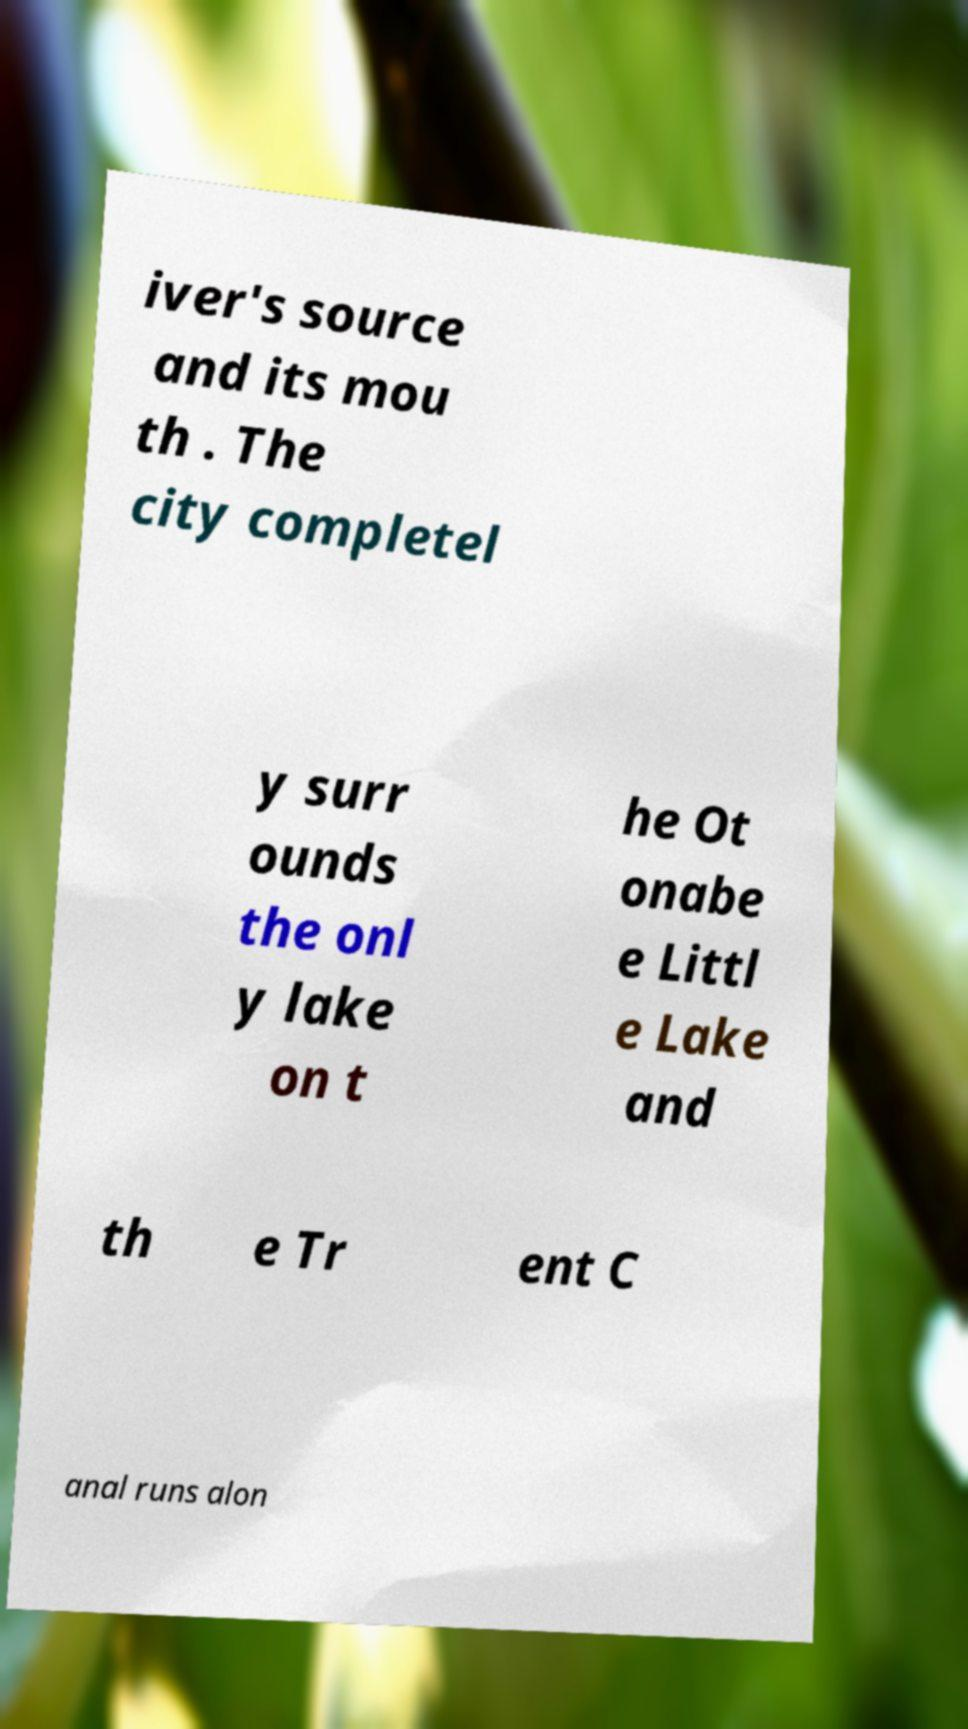What messages or text are displayed in this image? I need them in a readable, typed format. iver's source and its mou th . The city completel y surr ounds the onl y lake on t he Ot onabe e Littl e Lake and th e Tr ent C anal runs alon 